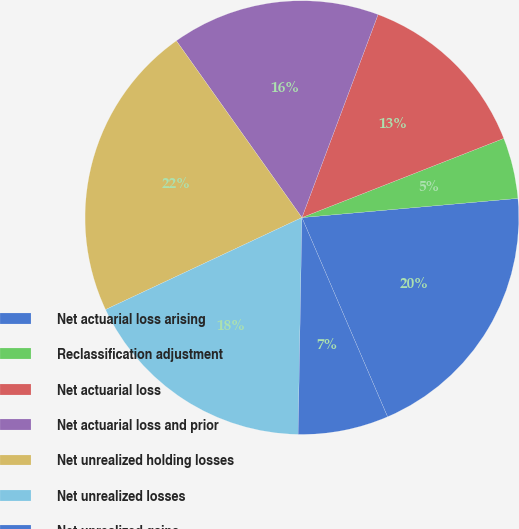Convert chart. <chart><loc_0><loc_0><loc_500><loc_500><pie_chart><fcel>Net actuarial loss arising<fcel>Reclassification adjustment<fcel>Net actuarial loss<fcel>Net actuarial loss and prior<fcel>Net unrealized holding losses<fcel>Net unrealized losses<fcel>Net unrealized gains<nl><fcel>19.95%<fcel>4.54%<fcel>13.34%<fcel>15.54%<fcel>22.15%<fcel>17.75%<fcel>6.74%<nl></chart> 